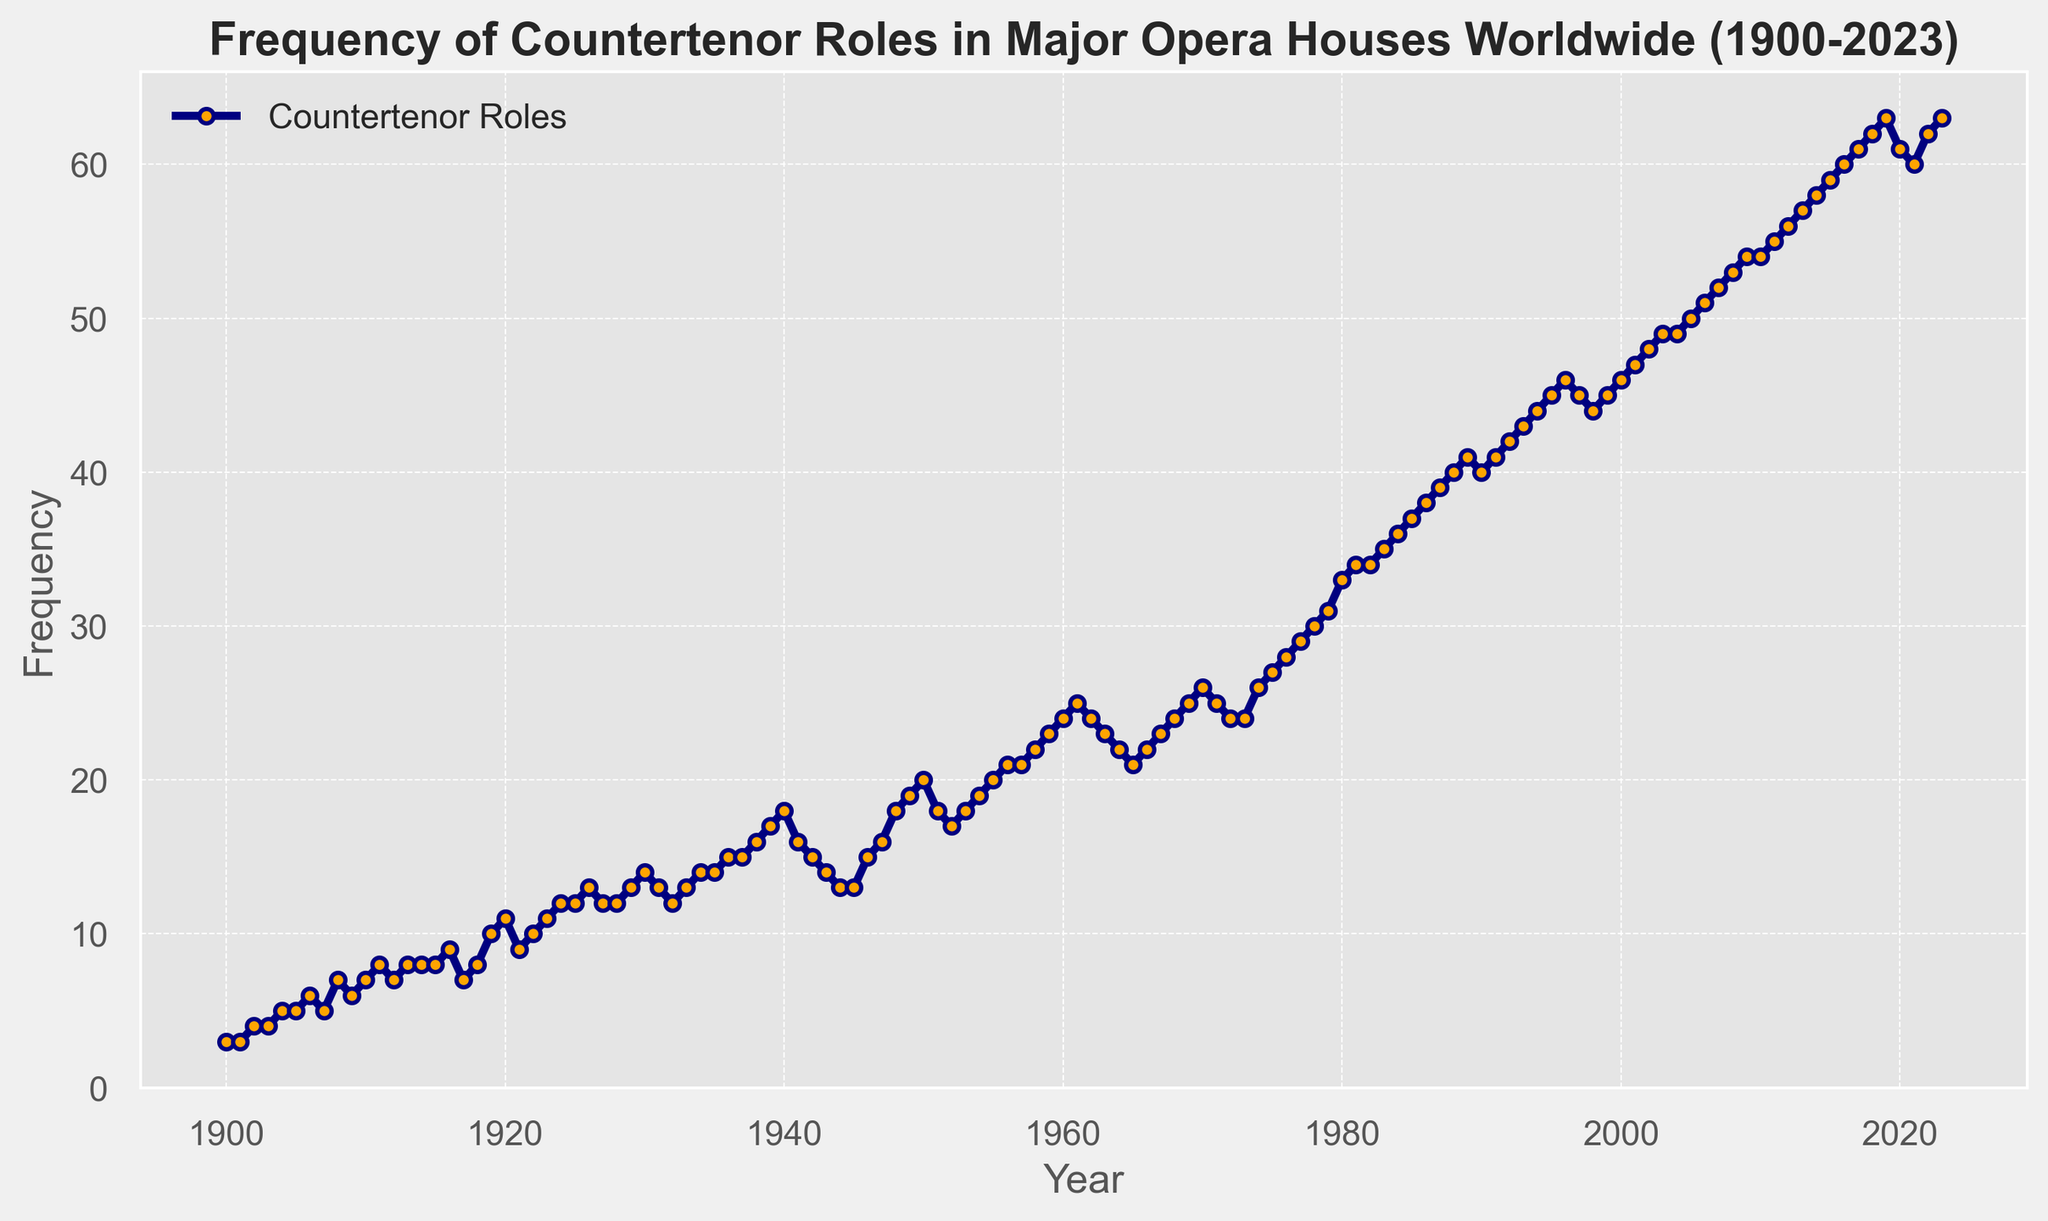What is the general trend in the frequency of countertenor roles from 1900 to 2023? The line chart generally shows a rising trend in the frequency of countertenor roles from 1900 to 2023, with fluctuations along the way.
Answer: Increasing Which year shows the highest frequency of countertenor roles? By observing the data in the line chart, the year 2023 has the highest recorded frequency of countertenor roles.
Answer: 2023 Between 1950 and 1960, which year shows the highest increase in countertenor roles from the previous year? From 1950 to 1960, 1959 shows the highest increase in countertenor roles, with an increase from 22 to 23.
Answer: 1959 What was the frequency of countertenor roles in 1940? The frequency of countertenor roles in 1940, according to the line chart, is 18.
Answer: 18 Compare the frequency of countertenor roles in the years 2000 and 2010. Which one was higher and by how much? The frequency in 2000 is 46, and in 2010 it is 54. The frequency was higher in 2010 by 8 roles.
Answer: 2010, by 8 roles Calculate the average frequency of countertenor roles for the decade 1980-1989. Sum the frequencies from 1980 to 1989 (33+34+34+35+36+37+38+39+40+41) = 367, then divide by 10. The average frequency is 367/10 = 36.7.
Answer: 36.7 Identify a period where there was a significant decline in the frequency of countertenor roles. Between 1996 and 1998, the frequency declined from 46 to 44.
Answer: 1996-1998 In which year did the frequency of countertenor roles first reach 50? The chart shows that the frequency first reached 50 in the year 2005.
Answer: 2005 What is the difference between the highest and lowest recorded frequencies in the entire dataset? The highest recorded frequency is 63 in 2023, and the lowest recorded frequency is 3 in 1900 and 1901, giving a difference of 63 - 3 = 60.
Answer: 60 